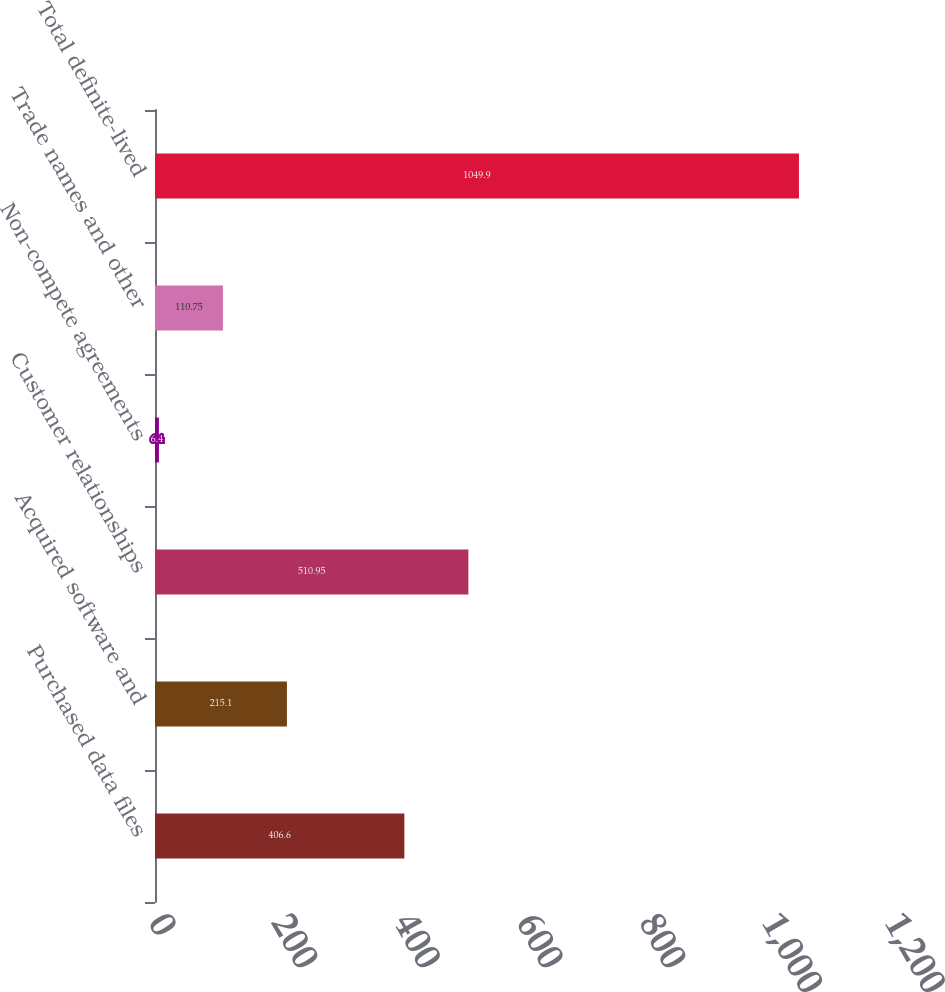Convert chart. <chart><loc_0><loc_0><loc_500><loc_500><bar_chart><fcel>Purchased data files<fcel>Acquired software and<fcel>Customer relationships<fcel>Non-compete agreements<fcel>Trade names and other<fcel>Total definite-lived<nl><fcel>406.6<fcel>215.1<fcel>510.95<fcel>6.4<fcel>110.75<fcel>1049.9<nl></chart> 